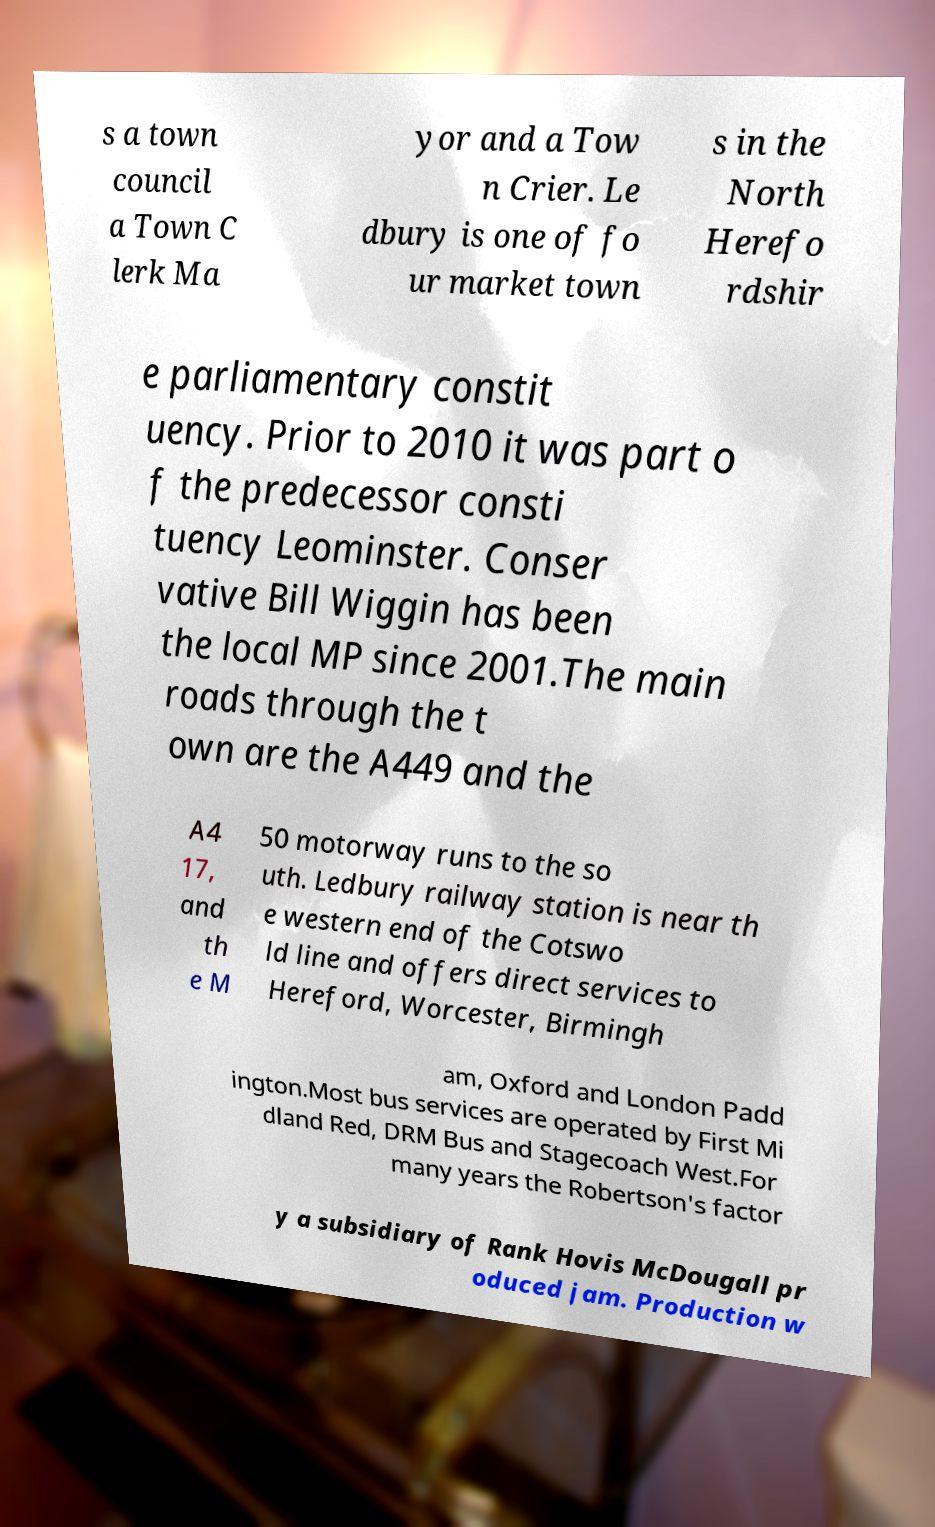Can you read and provide the text displayed in the image?This photo seems to have some interesting text. Can you extract and type it out for me? s a town council a Town C lerk Ma yor and a Tow n Crier. Le dbury is one of fo ur market town s in the North Herefo rdshir e parliamentary constit uency. Prior to 2010 it was part o f the predecessor consti tuency Leominster. Conser vative Bill Wiggin has been the local MP since 2001.The main roads through the t own are the A449 and the A4 17, and th e M 50 motorway runs to the so uth. Ledbury railway station is near th e western end of the Cotswo ld line and offers direct services to Hereford, Worcester, Birmingh am, Oxford and London Padd ington.Most bus services are operated by First Mi dland Red, DRM Bus and Stagecoach West.For many years the Robertson's factor y a subsidiary of Rank Hovis McDougall pr oduced jam. Production w 